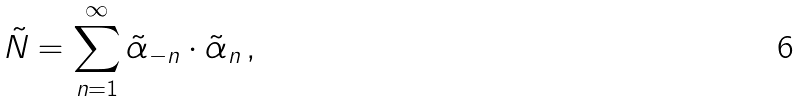<formula> <loc_0><loc_0><loc_500><loc_500>\tilde { N } = \sum _ { n = 1 } ^ { \infty } \tilde { \alpha } _ { - n } \cdot \tilde { \alpha } _ { n } \, ,</formula> 